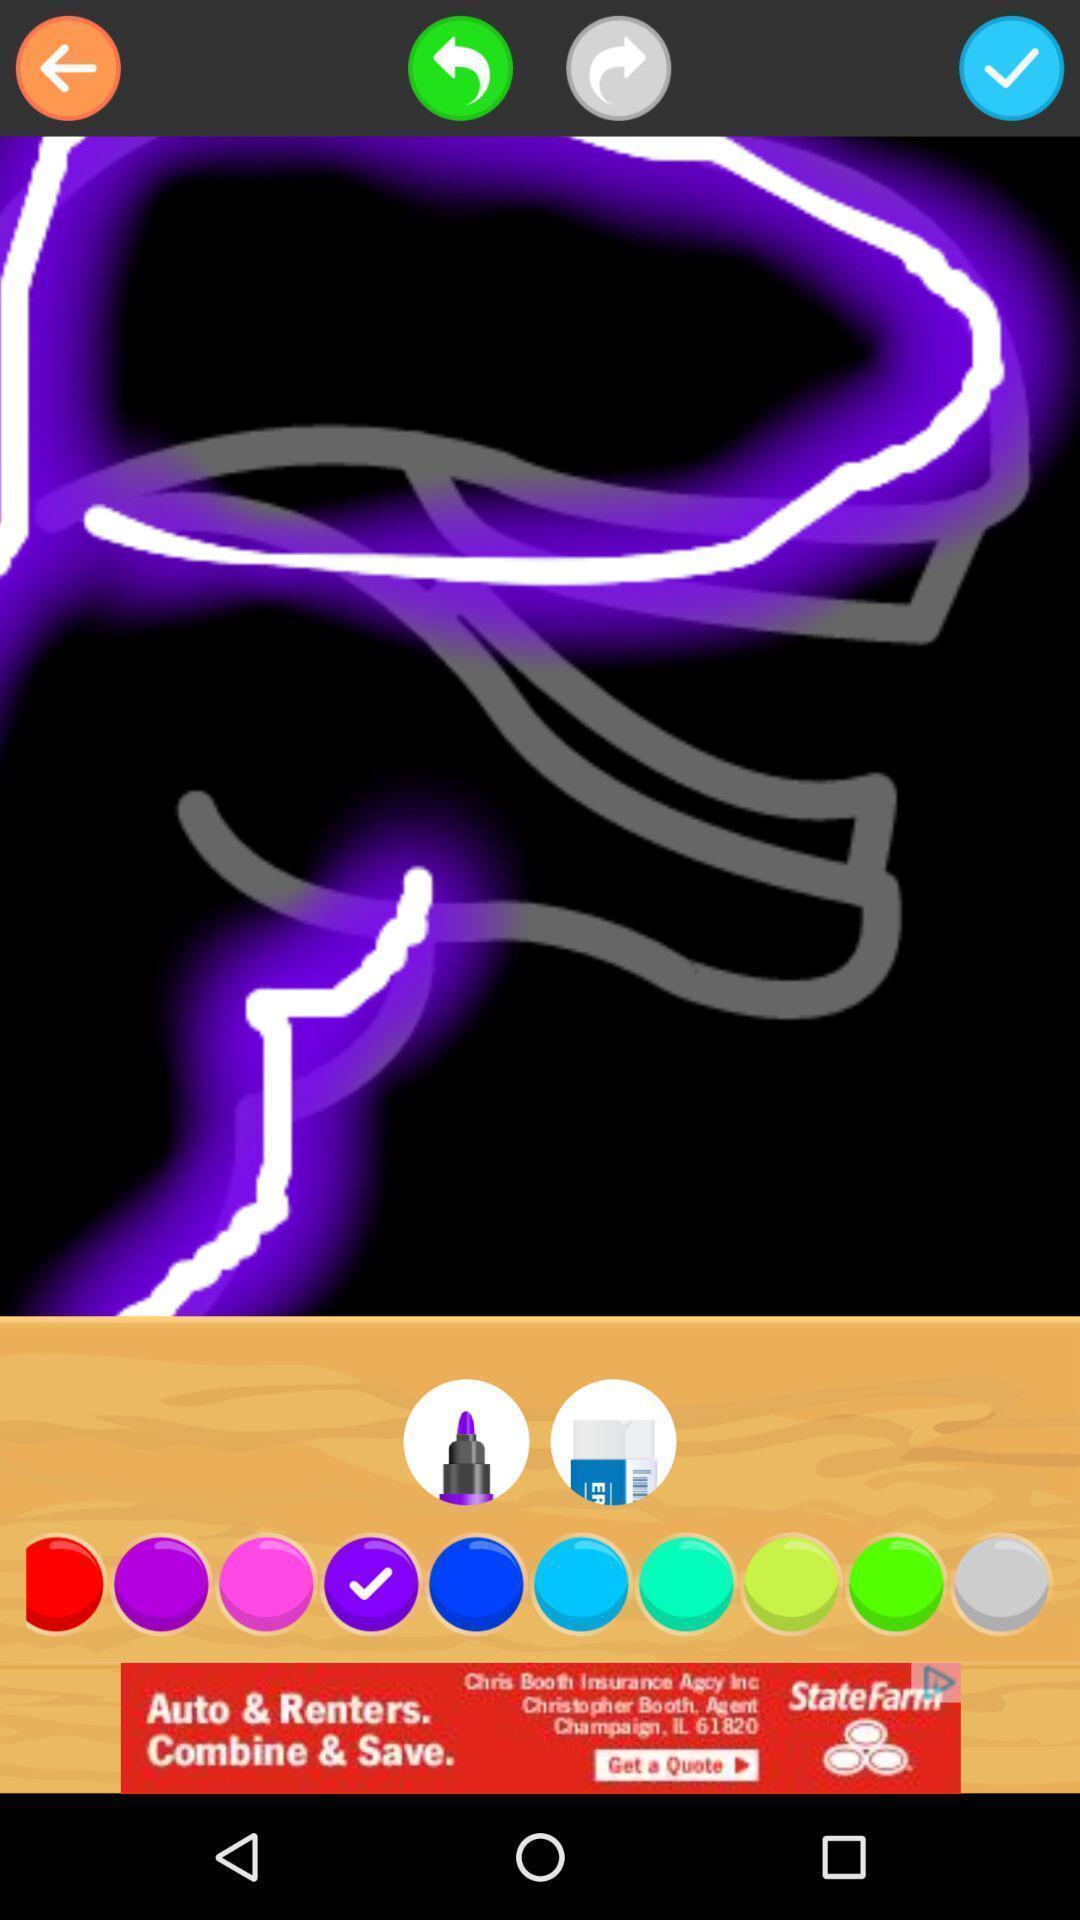Give me a summary of this screen capture. Page of a drawing application. 